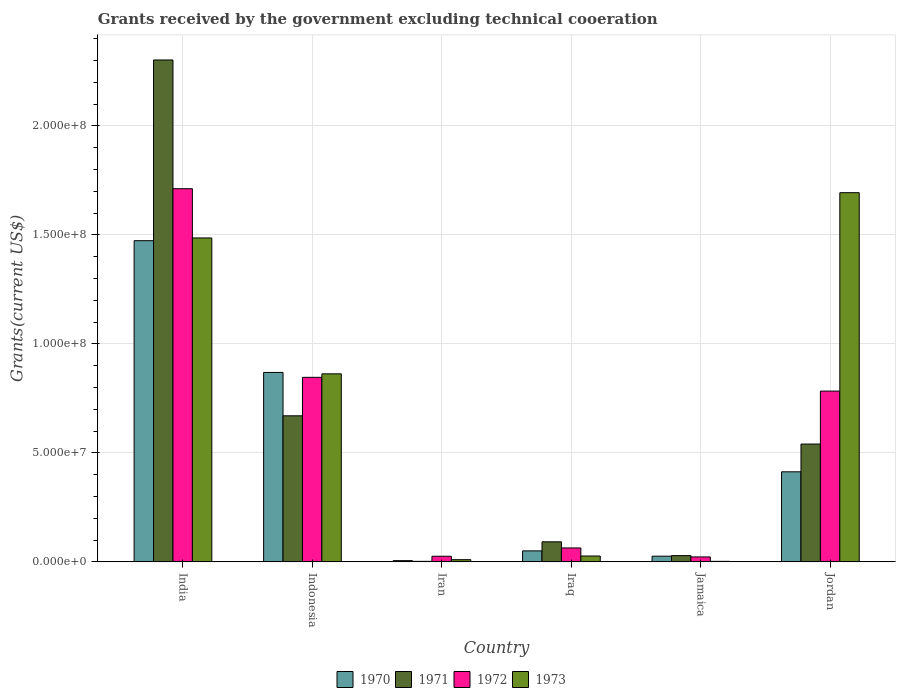Are the number of bars on each tick of the X-axis equal?
Offer a terse response. Yes. How many bars are there on the 6th tick from the right?
Your answer should be compact. 4. What is the label of the 3rd group of bars from the left?
Your answer should be compact. Iran. In how many cases, is the number of bars for a given country not equal to the number of legend labels?
Provide a succinct answer. 0. What is the total grants received by the government in 1973 in Indonesia?
Make the answer very short. 8.63e+07. Across all countries, what is the maximum total grants received by the government in 1970?
Offer a very short reply. 1.47e+08. Across all countries, what is the minimum total grants received by the government in 1973?
Keep it short and to the point. 2.50e+05. In which country was the total grants received by the government in 1972 maximum?
Give a very brief answer. India. In which country was the total grants received by the government in 1971 minimum?
Provide a succinct answer. Iran. What is the total total grants received by the government in 1971 in the graph?
Your response must be concise. 3.64e+08. What is the difference between the total grants received by the government in 1972 in Iran and that in Jamaica?
Ensure brevity in your answer.  3.10e+05. What is the difference between the total grants received by the government in 1972 in Iran and the total grants received by the government in 1970 in Jordan?
Give a very brief answer. -3.87e+07. What is the average total grants received by the government in 1973 per country?
Your answer should be very brief. 6.80e+07. What is the difference between the total grants received by the government of/in 1972 and total grants received by the government of/in 1971 in Indonesia?
Give a very brief answer. 1.76e+07. In how many countries, is the total grants received by the government in 1973 greater than 120000000 US$?
Provide a succinct answer. 2. What is the ratio of the total grants received by the government in 1970 in India to that in Jordan?
Provide a succinct answer. 3.57. What is the difference between the highest and the second highest total grants received by the government in 1973?
Offer a very short reply. 8.31e+07. What is the difference between the highest and the lowest total grants received by the government in 1972?
Offer a terse response. 1.69e+08. What does the 2nd bar from the left in Iraq represents?
Ensure brevity in your answer.  1971. What does the 3rd bar from the right in Jamaica represents?
Make the answer very short. 1971. Is it the case that in every country, the sum of the total grants received by the government in 1972 and total grants received by the government in 1970 is greater than the total grants received by the government in 1973?
Give a very brief answer. No. Are all the bars in the graph horizontal?
Ensure brevity in your answer.  No. How many countries are there in the graph?
Ensure brevity in your answer.  6. What is the difference between two consecutive major ticks on the Y-axis?
Give a very brief answer. 5.00e+07. Does the graph contain any zero values?
Keep it short and to the point. No. Does the graph contain grids?
Your answer should be compact. Yes. Where does the legend appear in the graph?
Your answer should be compact. Bottom center. How are the legend labels stacked?
Your answer should be compact. Horizontal. What is the title of the graph?
Give a very brief answer. Grants received by the government excluding technical cooeration. What is the label or title of the X-axis?
Give a very brief answer. Country. What is the label or title of the Y-axis?
Your answer should be compact. Grants(current US$). What is the Grants(current US$) in 1970 in India?
Offer a very short reply. 1.47e+08. What is the Grants(current US$) of 1971 in India?
Ensure brevity in your answer.  2.30e+08. What is the Grants(current US$) of 1972 in India?
Offer a terse response. 1.71e+08. What is the Grants(current US$) of 1973 in India?
Keep it short and to the point. 1.49e+08. What is the Grants(current US$) in 1970 in Indonesia?
Provide a succinct answer. 8.69e+07. What is the Grants(current US$) of 1971 in Indonesia?
Your answer should be very brief. 6.70e+07. What is the Grants(current US$) in 1972 in Indonesia?
Offer a terse response. 8.47e+07. What is the Grants(current US$) of 1973 in Indonesia?
Offer a very short reply. 8.63e+07. What is the Grants(current US$) of 1970 in Iran?
Your answer should be compact. 5.60e+05. What is the Grants(current US$) in 1971 in Iran?
Make the answer very short. 2.40e+05. What is the Grants(current US$) in 1972 in Iran?
Provide a short and direct response. 2.58e+06. What is the Grants(current US$) in 1973 in Iran?
Provide a short and direct response. 1.01e+06. What is the Grants(current US$) in 1970 in Iraq?
Provide a succinct answer. 5.04e+06. What is the Grants(current US$) of 1971 in Iraq?
Your answer should be compact. 9.20e+06. What is the Grants(current US$) of 1972 in Iraq?
Give a very brief answer. 6.39e+06. What is the Grants(current US$) of 1973 in Iraq?
Make the answer very short. 2.69e+06. What is the Grants(current US$) in 1970 in Jamaica?
Provide a short and direct response. 2.61e+06. What is the Grants(current US$) in 1971 in Jamaica?
Keep it short and to the point. 2.87e+06. What is the Grants(current US$) in 1972 in Jamaica?
Make the answer very short. 2.27e+06. What is the Grants(current US$) of 1970 in Jordan?
Offer a terse response. 4.13e+07. What is the Grants(current US$) in 1971 in Jordan?
Provide a succinct answer. 5.41e+07. What is the Grants(current US$) of 1972 in Jordan?
Make the answer very short. 7.84e+07. What is the Grants(current US$) in 1973 in Jordan?
Give a very brief answer. 1.69e+08. Across all countries, what is the maximum Grants(current US$) in 1970?
Offer a very short reply. 1.47e+08. Across all countries, what is the maximum Grants(current US$) of 1971?
Give a very brief answer. 2.30e+08. Across all countries, what is the maximum Grants(current US$) of 1972?
Your response must be concise. 1.71e+08. Across all countries, what is the maximum Grants(current US$) in 1973?
Keep it short and to the point. 1.69e+08. Across all countries, what is the minimum Grants(current US$) in 1970?
Make the answer very short. 5.60e+05. Across all countries, what is the minimum Grants(current US$) of 1971?
Give a very brief answer. 2.40e+05. Across all countries, what is the minimum Grants(current US$) of 1972?
Your answer should be very brief. 2.27e+06. Across all countries, what is the minimum Grants(current US$) of 1973?
Your answer should be compact. 2.50e+05. What is the total Grants(current US$) of 1970 in the graph?
Make the answer very short. 2.84e+08. What is the total Grants(current US$) in 1971 in the graph?
Your answer should be very brief. 3.64e+08. What is the total Grants(current US$) of 1972 in the graph?
Ensure brevity in your answer.  3.45e+08. What is the total Grants(current US$) of 1973 in the graph?
Give a very brief answer. 4.08e+08. What is the difference between the Grants(current US$) of 1970 in India and that in Indonesia?
Your answer should be compact. 6.04e+07. What is the difference between the Grants(current US$) of 1971 in India and that in Indonesia?
Your response must be concise. 1.63e+08. What is the difference between the Grants(current US$) of 1972 in India and that in Indonesia?
Offer a very short reply. 8.65e+07. What is the difference between the Grants(current US$) of 1973 in India and that in Indonesia?
Provide a short and direct response. 6.23e+07. What is the difference between the Grants(current US$) of 1970 in India and that in Iran?
Keep it short and to the point. 1.47e+08. What is the difference between the Grants(current US$) of 1971 in India and that in Iran?
Provide a short and direct response. 2.30e+08. What is the difference between the Grants(current US$) in 1972 in India and that in Iran?
Your answer should be compact. 1.69e+08. What is the difference between the Grants(current US$) in 1973 in India and that in Iran?
Make the answer very short. 1.48e+08. What is the difference between the Grants(current US$) of 1970 in India and that in Iraq?
Provide a succinct answer. 1.42e+08. What is the difference between the Grants(current US$) in 1971 in India and that in Iraq?
Provide a short and direct response. 2.21e+08. What is the difference between the Grants(current US$) of 1972 in India and that in Iraq?
Keep it short and to the point. 1.65e+08. What is the difference between the Grants(current US$) in 1973 in India and that in Iraq?
Your answer should be compact. 1.46e+08. What is the difference between the Grants(current US$) in 1970 in India and that in Jamaica?
Offer a terse response. 1.45e+08. What is the difference between the Grants(current US$) of 1971 in India and that in Jamaica?
Keep it short and to the point. 2.27e+08. What is the difference between the Grants(current US$) of 1972 in India and that in Jamaica?
Keep it short and to the point. 1.69e+08. What is the difference between the Grants(current US$) of 1973 in India and that in Jamaica?
Your answer should be very brief. 1.48e+08. What is the difference between the Grants(current US$) of 1970 in India and that in Jordan?
Provide a short and direct response. 1.06e+08. What is the difference between the Grants(current US$) of 1971 in India and that in Jordan?
Offer a very short reply. 1.76e+08. What is the difference between the Grants(current US$) of 1972 in India and that in Jordan?
Your response must be concise. 9.28e+07. What is the difference between the Grants(current US$) in 1973 in India and that in Jordan?
Ensure brevity in your answer.  -2.08e+07. What is the difference between the Grants(current US$) of 1970 in Indonesia and that in Iran?
Make the answer very short. 8.64e+07. What is the difference between the Grants(current US$) in 1971 in Indonesia and that in Iran?
Give a very brief answer. 6.68e+07. What is the difference between the Grants(current US$) of 1972 in Indonesia and that in Iran?
Give a very brief answer. 8.21e+07. What is the difference between the Grants(current US$) of 1973 in Indonesia and that in Iran?
Ensure brevity in your answer.  8.53e+07. What is the difference between the Grants(current US$) in 1970 in Indonesia and that in Iraq?
Your response must be concise. 8.19e+07. What is the difference between the Grants(current US$) of 1971 in Indonesia and that in Iraq?
Provide a short and direct response. 5.78e+07. What is the difference between the Grants(current US$) in 1972 in Indonesia and that in Iraq?
Ensure brevity in your answer.  7.83e+07. What is the difference between the Grants(current US$) in 1973 in Indonesia and that in Iraq?
Offer a very short reply. 8.36e+07. What is the difference between the Grants(current US$) in 1970 in Indonesia and that in Jamaica?
Make the answer very short. 8.43e+07. What is the difference between the Grants(current US$) of 1971 in Indonesia and that in Jamaica?
Your answer should be compact. 6.41e+07. What is the difference between the Grants(current US$) in 1972 in Indonesia and that in Jamaica?
Make the answer very short. 8.24e+07. What is the difference between the Grants(current US$) in 1973 in Indonesia and that in Jamaica?
Ensure brevity in your answer.  8.60e+07. What is the difference between the Grants(current US$) in 1970 in Indonesia and that in Jordan?
Your response must be concise. 4.56e+07. What is the difference between the Grants(current US$) of 1971 in Indonesia and that in Jordan?
Offer a very short reply. 1.30e+07. What is the difference between the Grants(current US$) of 1972 in Indonesia and that in Jordan?
Ensure brevity in your answer.  6.31e+06. What is the difference between the Grants(current US$) in 1973 in Indonesia and that in Jordan?
Make the answer very short. -8.31e+07. What is the difference between the Grants(current US$) in 1970 in Iran and that in Iraq?
Provide a short and direct response. -4.48e+06. What is the difference between the Grants(current US$) in 1971 in Iran and that in Iraq?
Ensure brevity in your answer.  -8.96e+06. What is the difference between the Grants(current US$) in 1972 in Iran and that in Iraq?
Your answer should be compact. -3.81e+06. What is the difference between the Grants(current US$) in 1973 in Iran and that in Iraq?
Ensure brevity in your answer.  -1.68e+06. What is the difference between the Grants(current US$) in 1970 in Iran and that in Jamaica?
Give a very brief answer. -2.05e+06. What is the difference between the Grants(current US$) in 1971 in Iran and that in Jamaica?
Give a very brief answer. -2.63e+06. What is the difference between the Grants(current US$) in 1972 in Iran and that in Jamaica?
Provide a short and direct response. 3.10e+05. What is the difference between the Grants(current US$) in 1973 in Iran and that in Jamaica?
Keep it short and to the point. 7.60e+05. What is the difference between the Grants(current US$) of 1970 in Iran and that in Jordan?
Keep it short and to the point. -4.08e+07. What is the difference between the Grants(current US$) in 1971 in Iran and that in Jordan?
Give a very brief answer. -5.38e+07. What is the difference between the Grants(current US$) of 1972 in Iran and that in Jordan?
Give a very brief answer. -7.58e+07. What is the difference between the Grants(current US$) of 1973 in Iran and that in Jordan?
Offer a terse response. -1.68e+08. What is the difference between the Grants(current US$) of 1970 in Iraq and that in Jamaica?
Keep it short and to the point. 2.43e+06. What is the difference between the Grants(current US$) of 1971 in Iraq and that in Jamaica?
Offer a terse response. 6.33e+06. What is the difference between the Grants(current US$) of 1972 in Iraq and that in Jamaica?
Offer a very short reply. 4.12e+06. What is the difference between the Grants(current US$) of 1973 in Iraq and that in Jamaica?
Offer a terse response. 2.44e+06. What is the difference between the Grants(current US$) in 1970 in Iraq and that in Jordan?
Your answer should be compact. -3.63e+07. What is the difference between the Grants(current US$) of 1971 in Iraq and that in Jordan?
Ensure brevity in your answer.  -4.49e+07. What is the difference between the Grants(current US$) of 1972 in Iraq and that in Jordan?
Give a very brief answer. -7.20e+07. What is the difference between the Grants(current US$) in 1973 in Iraq and that in Jordan?
Make the answer very short. -1.67e+08. What is the difference between the Grants(current US$) in 1970 in Jamaica and that in Jordan?
Provide a succinct answer. -3.87e+07. What is the difference between the Grants(current US$) of 1971 in Jamaica and that in Jordan?
Your answer should be compact. -5.12e+07. What is the difference between the Grants(current US$) in 1972 in Jamaica and that in Jordan?
Give a very brief answer. -7.61e+07. What is the difference between the Grants(current US$) in 1973 in Jamaica and that in Jordan?
Your answer should be compact. -1.69e+08. What is the difference between the Grants(current US$) of 1970 in India and the Grants(current US$) of 1971 in Indonesia?
Keep it short and to the point. 8.03e+07. What is the difference between the Grants(current US$) of 1970 in India and the Grants(current US$) of 1972 in Indonesia?
Provide a succinct answer. 6.27e+07. What is the difference between the Grants(current US$) of 1970 in India and the Grants(current US$) of 1973 in Indonesia?
Make the answer very short. 6.11e+07. What is the difference between the Grants(current US$) in 1971 in India and the Grants(current US$) in 1972 in Indonesia?
Your answer should be very brief. 1.46e+08. What is the difference between the Grants(current US$) of 1971 in India and the Grants(current US$) of 1973 in Indonesia?
Provide a short and direct response. 1.44e+08. What is the difference between the Grants(current US$) in 1972 in India and the Grants(current US$) in 1973 in Indonesia?
Make the answer very short. 8.49e+07. What is the difference between the Grants(current US$) of 1970 in India and the Grants(current US$) of 1971 in Iran?
Ensure brevity in your answer.  1.47e+08. What is the difference between the Grants(current US$) in 1970 in India and the Grants(current US$) in 1972 in Iran?
Make the answer very short. 1.45e+08. What is the difference between the Grants(current US$) of 1970 in India and the Grants(current US$) of 1973 in Iran?
Make the answer very short. 1.46e+08. What is the difference between the Grants(current US$) in 1971 in India and the Grants(current US$) in 1972 in Iran?
Provide a succinct answer. 2.28e+08. What is the difference between the Grants(current US$) of 1971 in India and the Grants(current US$) of 1973 in Iran?
Offer a very short reply. 2.29e+08. What is the difference between the Grants(current US$) of 1972 in India and the Grants(current US$) of 1973 in Iran?
Make the answer very short. 1.70e+08. What is the difference between the Grants(current US$) in 1970 in India and the Grants(current US$) in 1971 in Iraq?
Your answer should be very brief. 1.38e+08. What is the difference between the Grants(current US$) in 1970 in India and the Grants(current US$) in 1972 in Iraq?
Keep it short and to the point. 1.41e+08. What is the difference between the Grants(current US$) of 1970 in India and the Grants(current US$) of 1973 in Iraq?
Give a very brief answer. 1.45e+08. What is the difference between the Grants(current US$) of 1971 in India and the Grants(current US$) of 1972 in Iraq?
Give a very brief answer. 2.24e+08. What is the difference between the Grants(current US$) of 1971 in India and the Grants(current US$) of 1973 in Iraq?
Provide a succinct answer. 2.28e+08. What is the difference between the Grants(current US$) of 1972 in India and the Grants(current US$) of 1973 in Iraq?
Offer a terse response. 1.69e+08. What is the difference between the Grants(current US$) of 1970 in India and the Grants(current US$) of 1971 in Jamaica?
Keep it short and to the point. 1.44e+08. What is the difference between the Grants(current US$) in 1970 in India and the Grants(current US$) in 1972 in Jamaica?
Your answer should be compact. 1.45e+08. What is the difference between the Grants(current US$) in 1970 in India and the Grants(current US$) in 1973 in Jamaica?
Provide a short and direct response. 1.47e+08. What is the difference between the Grants(current US$) in 1971 in India and the Grants(current US$) in 1972 in Jamaica?
Offer a very short reply. 2.28e+08. What is the difference between the Grants(current US$) of 1971 in India and the Grants(current US$) of 1973 in Jamaica?
Ensure brevity in your answer.  2.30e+08. What is the difference between the Grants(current US$) in 1972 in India and the Grants(current US$) in 1973 in Jamaica?
Make the answer very short. 1.71e+08. What is the difference between the Grants(current US$) in 1970 in India and the Grants(current US$) in 1971 in Jordan?
Provide a succinct answer. 9.33e+07. What is the difference between the Grants(current US$) of 1970 in India and the Grants(current US$) of 1972 in Jordan?
Offer a very short reply. 6.90e+07. What is the difference between the Grants(current US$) of 1970 in India and the Grants(current US$) of 1973 in Jordan?
Provide a succinct answer. -2.20e+07. What is the difference between the Grants(current US$) of 1971 in India and the Grants(current US$) of 1972 in Jordan?
Ensure brevity in your answer.  1.52e+08. What is the difference between the Grants(current US$) in 1971 in India and the Grants(current US$) in 1973 in Jordan?
Your answer should be very brief. 6.09e+07. What is the difference between the Grants(current US$) of 1972 in India and the Grants(current US$) of 1973 in Jordan?
Offer a very short reply. 1.82e+06. What is the difference between the Grants(current US$) in 1970 in Indonesia and the Grants(current US$) in 1971 in Iran?
Give a very brief answer. 8.67e+07. What is the difference between the Grants(current US$) of 1970 in Indonesia and the Grants(current US$) of 1972 in Iran?
Your response must be concise. 8.43e+07. What is the difference between the Grants(current US$) of 1970 in Indonesia and the Grants(current US$) of 1973 in Iran?
Give a very brief answer. 8.59e+07. What is the difference between the Grants(current US$) of 1971 in Indonesia and the Grants(current US$) of 1972 in Iran?
Give a very brief answer. 6.44e+07. What is the difference between the Grants(current US$) in 1971 in Indonesia and the Grants(current US$) in 1973 in Iran?
Make the answer very short. 6.60e+07. What is the difference between the Grants(current US$) in 1972 in Indonesia and the Grants(current US$) in 1973 in Iran?
Make the answer very short. 8.36e+07. What is the difference between the Grants(current US$) of 1970 in Indonesia and the Grants(current US$) of 1971 in Iraq?
Provide a short and direct response. 7.77e+07. What is the difference between the Grants(current US$) in 1970 in Indonesia and the Grants(current US$) in 1972 in Iraq?
Offer a very short reply. 8.05e+07. What is the difference between the Grants(current US$) of 1970 in Indonesia and the Grants(current US$) of 1973 in Iraq?
Ensure brevity in your answer.  8.42e+07. What is the difference between the Grants(current US$) of 1971 in Indonesia and the Grants(current US$) of 1972 in Iraq?
Your answer should be compact. 6.06e+07. What is the difference between the Grants(current US$) in 1971 in Indonesia and the Grants(current US$) in 1973 in Iraq?
Your response must be concise. 6.43e+07. What is the difference between the Grants(current US$) in 1972 in Indonesia and the Grants(current US$) in 1973 in Iraq?
Ensure brevity in your answer.  8.20e+07. What is the difference between the Grants(current US$) in 1970 in Indonesia and the Grants(current US$) in 1971 in Jamaica?
Your response must be concise. 8.40e+07. What is the difference between the Grants(current US$) in 1970 in Indonesia and the Grants(current US$) in 1972 in Jamaica?
Your answer should be compact. 8.46e+07. What is the difference between the Grants(current US$) of 1970 in Indonesia and the Grants(current US$) of 1973 in Jamaica?
Your response must be concise. 8.67e+07. What is the difference between the Grants(current US$) in 1971 in Indonesia and the Grants(current US$) in 1972 in Jamaica?
Give a very brief answer. 6.47e+07. What is the difference between the Grants(current US$) in 1971 in Indonesia and the Grants(current US$) in 1973 in Jamaica?
Provide a succinct answer. 6.68e+07. What is the difference between the Grants(current US$) in 1972 in Indonesia and the Grants(current US$) in 1973 in Jamaica?
Provide a short and direct response. 8.44e+07. What is the difference between the Grants(current US$) of 1970 in Indonesia and the Grants(current US$) of 1971 in Jordan?
Keep it short and to the point. 3.28e+07. What is the difference between the Grants(current US$) of 1970 in Indonesia and the Grants(current US$) of 1972 in Jordan?
Ensure brevity in your answer.  8.56e+06. What is the difference between the Grants(current US$) of 1970 in Indonesia and the Grants(current US$) of 1973 in Jordan?
Your answer should be compact. -8.25e+07. What is the difference between the Grants(current US$) in 1971 in Indonesia and the Grants(current US$) in 1972 in Jordan?
Provide a short and direct response. -1.13e+07. What is the difference between the Grants(current US$) of 1971 in Indonesia and the Grants(current US$) of 1973 in Jordan?
Give a very brief answer. -1.02e+08. What is the difference between the Grants(current US$) of 1972 in Indonesia and the Grants(current US$) of 1973 in Jordan?
Offer a terse response. -8.47e+07. What is the difference between the Grants(current US$) in 1970 in Iran and the Grants(current US$) in 1971 in Iraq?
Make the answer very short. -8.64e+06. What is the difference between the Grants(current US$) in 1970 in Iran and the Grants(current US$) in 1972 in Iraq?
Give a very brief answer. -5.83e+06. What is the difference between the Grants(current US$) in 1970 in Iran and the Grants(current US$) in 1973 in Iraq?
Provide a short and direct response. -2.13e+06. What is the difference between the Grants(current US$) in 1971 in Iran and the Grants(current US$) in 1972 in Iraq?
Keep it short and to the point. -6.15e+06. What is the difference between the Grants(current US$) in 1971 in Iran and the Grants(current US$) in 1973 in Iraq?
Keep it short and to the point. -2.45e+06. What is the difference between the Grants(current US$) of 1972 in Iran and the Grants(current US$) of 1973 in Iraq?
Your response must be concise. -1.10e+05. What is the difference between the Grants(current US$) in 1970 in Iran and the Grants(current US$) in 1971 in Jamaica?
Provide a short and direct response. -2.31e+06. What is the difference between the Grants(current US$) of 1970 in Iran and the Grants(current US$) of 1972 in Jamaica?
Provide a short and direct response. -1.71e+06. What is the difference between the Grants(current US$) of 1971 in Iran and the Grants(current US$) of 1972 in Jamaica?
Offer a terse response. -2.03e+06. What is the difference between the Grants(current US$) of 1971 in Iran and the Grants(current US$) of 1973 in Jamaica?
Your answer should be very brief. -10000. What is the difference between the Grants(current US$) of 1972 in Iran and the Grants(current US$) of 1973 in Jamaica?
Offer a terse response. 2.33e+06. What is the difference between the Grants(current US$) in 1970 in Iran and the Grants(current US$) in 1971 in Jordan?
Your answer should be very brief. -5.35e+07. What is the difference between the Grants(current US$) of 1970 in Iran and the Grants(current US$) of 1972 in Jordan?
Provide a short and direct response. -7.78e+07. What is the difference between the Grants(current US$) of 1970 in Iran and the Grants(current US$) of 1973 in Jordan?
Offer a terse response. -1.69e+08. What is the difference between the Grants(current US$) of 1971 in Iran and the Grants(current US$) of 1972 in Jordan?
Your answer should be very brief. -7.81e+07. What is the difference between the Grants(current US$) in 1971 in Iran and the Grants(current US$) in 1973 in Jordan?
Keep it short and to the point. -1.69e+08. What is the difference between the Grants(current US$) in 1972 in Iran and the Grants(current US$) in 1973 in Jordan?
Your response must be concise. -1.67e+08. What is the difference between the Grants(current US$) in 1970 in Iraq and the Grants(current US$) in 1971 in Jamaica?
Your response must be concise. 2.17e+06. What is the difference between the Grants(current US$) in 1970 in Iraq and the Grants(current US$) in 1972 in Jamaica?
Make the answer very short. 2.77e+06. What is the difference between the Grants(current US$) of 1970 in Iraq and the Grants(current US$) of 1973 in Jamaica?
Your answer should be very brief. 4.79e+06. What is the difference between the Grants(current US$) of 1971 in Iraq and the Grants(current US$) of 1972 in Jamaica?
Offer a terse response. 6.93e+06. What is the difference between the Grants(current US$) in 1971 in Iraq and the Grants(current US$) in 1973 in Jamaica?
Your response must be concise. 8.95e+06. What is the difference between the Grants(current US$) in 1972 in Iraq and the Grants(current US$) in 1973 in Jamaica?
Offer a terse response. 6.14e+06. What is the difference between the Grants(current US$) in 1970 in Iraq and the Grants(current US$) in 1971 in Jordan?
Make the answer very short. -4.90e+07. What is the difference between the Grants(current US$) of 1970 in Iraq and the Grants(current US$) of 1972 in Jordan?
Provide a short and direct response. -7.33e+07. What is the difference between the Grants(current US$) of 1970 in Iraq and the Grants(current US$) of 1973 in Jordan?
Give a very brief answer. -1.64e+08. What is the difference between the Grants(current US$) of 1971 in Iraq and the Grants(current US$) of 1972 in Jordan?
Your answer should be very brief. -6.92e+07. What is the difference between the Grants(current US$) of 1971 in Iraq and the Grants(current US$) of 1973 in Jordan?
Ensure brevity in your answer.  -1.60e+08. What is the difference between the Grants(current US$) in 1972 in Iraq and the Grants(current US$) in 1973 in Jordan?
Your response must be concise. -1.63e+08. What is the difference between the Grants(current US$) in 1970 in Jamaica and the Grants(current US$) in 1971 in Jordan?
Offer a very short reply. -5.14e+07. What is the difference between the Grants(current US$) of 1970 in Jamaica and the Grants(current US$) of 1972 in Jordan?
Offer a terse response. -7.57e+07. What is the difference between the Grants(current US$) in 1970 in Jamaica and the Grants(current US$) in 1973 in Jordan?
Provide a short and direct response. -1.67e+08. What is the difference between the Grants(current US$) in 1971 in Jamaica and the Grants(current US$) in 1972 in Jordan?
Ensure brevity in your answer.  -7.55e+07. What is the difference between the Grants(current US$) in 1971 in Jamaica and the Grants(current US$) in 1973 in Jordan?
Provide a succinct answer. -1.67e+08. What is the difference between the Grants(current US$) in 1972 in Jamaica and the Grants(current US$) in 1973 in Jordan?
Your answer should be compact. -1.67e+08. What is the average Grants(current US$) in 1970 per country?
Offer a very short reply. 4.73e+07. What is the average Grants(current US$) in 1971 per country?
Offer a terse response. 6.06e+07. What is the average Grants(current US$) of 1972 per country?
Provide a short and direct response. 5.76e+07. What is the average Grants(current US$) in 1973 per country?
Offer a terse response. 6.80e+07. What is the difference between the Grants(current US$) in 1970 and Grants(current US$) in 1971 in India?
Give a very brief answer. -8.29e+07. What is the difference between the Grants(current US$) in 1970 and Grants(current US$) in 1972 in India?
Make the answer very short. -2.38e+07. What is the difference between the Grants(current US$) of 1970 and Grants(current US$) of 1973 in India?
Make the answer very short. -1.26e+06. What is the difference between the Grants(current US$) in 1971 and Grants(current US$) in 1972 in India?
Your answer should be very brief. 5.91e+07. What is the difference between the Grants(current US$) in 1971 and Grants(current US$) in 1973 in India?
Your answer should be very brief. 8.16e+07. What is the difference between the Grants(current US$) in 1972 and Grants(current US$) in 1973 in India?
Your answer should be very brief. 2.26e+07. What is the difference between the Grants(current US$) in 1970 and Grants(current US$) in 1971 in Indonesia?
Ensure brevity in your answer.  1.99e+07. What is the difference between the Grants(current US$) in 1970 and Grants(current US$) in 1972 in Indonesia?
Give a very brief answer. 2.25e+06. What is the difference between the Grants(current US$) of 1970 and Grants(current US$) of 1973 in Indonesia?
Provide a short and direct response. 6.40e+05. What is the difference between the Grants(current US$) in 1971 and Grants(current US$) in 1972 in Indonesia?
Provide a short and direct response. -1.76e+07. What is the difference between the Grants(current US$) of 1971 and Grants(current US$) of 1973 in Indonesia?
Provide a succinct answer. -1.93e+07. What is the difference between the Grants(current US$) of 1972 and Grants(current US$) of 1973 in Indonesia?
Offer a terse response. -1.61e+06. What is the difference between the Grants(current US$) of 1970 and Grants(current US$) of 1971 in Iran?
Make the answer very short. 3.20e+05. What is the difference between the Grants(current US$) of 1970 and Grants(current US$) of 1972 in Iran?
Your answer should be compact. -2.02e+06. What is the difference between the Grants(current US$) of 1970 and Grants(current US$) of 1973 in Iran?
Your response must be concise. -4.50e+05. What is the difference between the Grants(current US$) in 1971 and Grants(current US$) in 1972 in Iran?
Offer a terse response. -2.34e+06. What is the difference between the Grants(current US$) of 1971 and Grants(current US$) of 1973 in Iran?
Provide a short and direct response. -7.70e+05. What is the difference between the Grants(current US$) in 1972 and Grants(current US$) in 1973 in Iran?
Offer a very short reply. 1.57e+06. What is the difference between the Grants(current US$) of 1970 and Grants(current US$) of 1971 in Iraq?
Make the answer very short. -4.16e+06. What is the difference between the Grants(current US$) of 1970 and Grants(current US$) of 1972 in Iraq?
Provide a succinct answer. -1.35e+06. What is the difference between the Grants(current US$) in 1970 and Grants(current US$) in 1973 in Iraq?
Ensure brevity in your answer.  2.35e+06. What is the difference between the Grants(current US$) of 1971 and Grants(current US$) of 1972 in Iraq?
Keep it short and to the point. 2.81e+06. What is the difference between the Grants(current US$) of 1971 and Grants(current US$) of 1973 in Iraq?
Ensure brevity in your answer.  6.51e+06. What is the difference between the Grants(current US$) of 1972 and Grants(current US$) of 1973 in Iraq?
Provide a succinct answer. 3.70e+06. What is the difference between the Grants(current US$) of 1970 and Grants(current US$) of 1972 in Jamaica?
Provide a succinct answer. 3.40e+05. What is the difference between the Grants(current US$) in 1970 and Grants(current US$) in 1973 in Jamaica?
Ensure brevity in your answer.  2.36e+06. What is the difference between the Grants(current US$) in 1971 and Grants(current US$) in 1972 in Jamaica?
Offer a terse response. 6.00e+05. What is the difference between the Grants(current US$) of 1971 and Grants(current US$) of 1973 in Jamaica?
Your answer should be very brief. 2.62e+06. What is the difference between the Grants(current US$) of 1972 and Grants(current US$) of 1973 in Jamaica?
Make the answer very short. 2.02e+06. What is the difference between the Grants(current US$) of 1970 and Grants(current US$) of 1971 in Jordan?
Ensure brevity in your answer.  -1.27e+07. What is the difference between the Grants(current US$) of 1970 and Grants(current US$) of 1972 in Jordan?
Make the answer very short. -3.70e+07. What is the difference between the Grants(current US$) of 1970 and Grants(current US$) of 1973 in Jordan?
Your answer should be very brief. -1.28e+08. What is the difference between the Grants(current US$) in 1971 and Grants(current US$) in 1972 in Jordan?
Provide a short and direct response. -2.43e+07. What is the difference between the Grants(current US$) of 1971 and Grants(current US$) of 1973 in Jordan?
Ensure brevity in your answer.  -1.15e+08. What is the difference between the Grants(current US$) of 1972 and Grants(current US$) of 1973 in Jordan?
Your answer should be compact. -9.10e+07. What is the ratio of the Grants(current US$) in 1970 in India to that in Indonesia?
Keep it short and to the point. 1.7. What is the ratio of the Grants(current US$) in 1971 in India to that in Indonesia?
Offer a very short reply. 3.44. What is the ratio of the Grants(current US$) of 1972 in India to that in Indonesia?
Keep it short and to the point. 2.02. What is the ratio of the Grants(current US$) of 1973 in India to that in Indonesia?
Keep it short and to the point. 1.72. What is the ratio of the Grants(current US$) in 1970 in India to that in Iran?
Ensure brevity in your answer.  263.12. What is the ratio of the Grants(current US$) of 1971 in India to that in Iran?
Provide a succinct answer. 959.42. What is the ratio of the Grants(current US$) in 1972 in India to that in Iran?
Your answer should be compact. 66.36. What is the ratio of the Grants(current US$) in 1973 in India to that in Iran?
Provide a succinct answer. 147.14. What is the ratio of the Grants(current US$) in 1970 in India to that in Iraq?
Offer a very short reply. 29.24. What is the ratio of the Grants(current US$) in 1971 in India to that in Iraq?
Your answer should be very brief. 25.03. What is the ratio of the Grants(current US$) of 1972 in India to that in Iraq?
Ensure brevity in your answer.  26.79. What is the ratio of the Grants(current US$) of 1973 in India to that in Iraq?
Your answer should be very brief. 55.25. What is the ratio of the Grants(current US$) of 1970 in India to that in Jamaica?
Offer a very short reply. 56.46. What is the ratio of the Grants(current US$) of 1971 in India to that in Jamaica?
Your answer should be compact. 80.23. What is the ratio of the Grants(current US$) of 1972 in India to that in Jamaica?
Provide a short and direct response. 75.42. What is the ratio of the Grants(current US$) in 1973 in India to that in Jamaica?
Offer a terse response. 594.44. What is the ratio of the Grants(current US$) in 1970 in India to that in Jordan?
Give a very brief answer. 3.57. What is the ratio of the Grants(current US$) of 1971 in India to that in Jordan?
Your response must be concise. 4.26. What is the ratio of the Grants(current US$) of 1972 in India to that in Jordan?
Your answer should be compact. 2.19. What is the ratio of the Grants(current US$) of 1973 in India to that in Jordan?
Your answer should be very brief. 0.88. What is the ratio of the Grants(current US$) in 1970 in Indonesia to that in Iran?
Give a very brief answer. 155.2. What is the ratio of the Grants(current US$) in 1971 in Indonesia to that in Iran?
Your answer should be very brief. 279.21. What is the ratio of the Grants(current US$) of 1972 in Indonesia to that in Iran?
Your response must be concise. 32.81. What is the ratio of the Grants(current US$) of 1973 in Indonesia to that in Iran?
Make the answer very short. 85.42. What is the ratio of the Grants(current US$) of 1970 in Indonesia to that in Iraq?
Your answer should be compact. 17.24. What is the ratio of the Grants(current US$) in 1971 in Indonesia to that in Iraq?
Provide a succinct answer. 7.28. What is the ratio of the Grants(current US$) of 1972 in Indonesia to that in Iraq?
Your response must be concise. 13.25. What is the ratio of the Grants(current US$) of 1973 in Indonesia to that in Iraq?
Provide a succinct answer. 32.07. What is the ratio of the Grants(current US$) in 1970 in Indonesia to that in Jamaica?
Offer a terse response. 33.3. What is the ratio of the Grants(current US$) of 1971 in Indonesia to that in Jamaica?
Offer a very short reply. 23.35. What is the ratio of the Grants(current US$) of 1972 in Indonesia to that in Jamaica?
Keep it short and to the point. 37.3. What is the ratio of the Grants(current US$) in 1973 in Indonesia to that in Jamaica?
Offer a very short reply. 345.08. What is the ratio of the Grants(current US$) in 1970 in Indonesia to that in Jordan?
Offer a very short reply. 2.1. What is the ratio of the Grants(current US$) in 1971 in Indonesia to that in Jordan?
Provide a succinct answer. 1.24. What is the ratio of the Grants(current US$) in 1972 in Indonesia to that in Jordan?
Ensure brevity in your answer.  1.08. What is the ratio of the Grants(current US$) of 1973 in Indonesia to that in Jordan?
Provide a succinct answer. 0.51. What is the ratio of the Grants(current US$) in 1971 in Iran to that in Iraq?
Give a very brief answer. 0.03. What is the ratio of the Grants(current US$) in 1972 in Iran to that in Iraq?
Ensure brevity in your answer.  0.4. What is the ratio of the Grants(current US$) of 1973 in Iran to that in Iraq?
Provide a succinct answer. 0.38. What is the ratio of the Grants(current US$) of 1970 in Iran to that in Jamaica?
Offer a terse response. 0.21. What is the ratio of the Grants(current US$) of 1971 in Iran to that in Jamaica?
Offer a very short reply. 0.08. What is the ratio of the Grants(current US$) of 1972 in Iran to that in Jamaica?
Make the answer very short. 1.14. What is the ratio of the Grants(current US$) in 1973 in Iran to that in Jamaica?
Your answer should be compact. 4.04. What is the ratio of the Grants(current US$) in 1970 in Iran to that in Jordan?
Ensure brevity in your answer.  0.01. What is the ratio of the Grants(current US$) of 1971 in Iran to that in Jordan?
Give a very brief answer. 0. What is the ratio of the Grants(current US$) in 1972 in Iran to that in Jordan?
Offer a terse response. 0.03. What is the ratio of the Grants(current US$) in 1973 in Iran to that in Jordan?
Make the answer very short. 0.01. What is the ratio of the Grants(current US$) of 1970 in Iraq to that in Jamaica?
Your response must be concise. 1.93. What is the ratio of the Grants(current US$) of 1971 in Iraq to that in Jamaica?
Ensure brevity in your answer.  3.21. What is the ratio of the Grants(current US$) in 1972 in Iraq to that in Jamaica?
Make the answer very short. 2.81. What is the ratio of the Grants(current US$) in 1973 in Iraq to that in Jamaica?
Your response must be concise. 10.76. What is the ratio of the Grants(current US$) of 1970 in Iraq to that in Jordan?
Provide a short and direct response. 0.12. What is the ratio of the Grants(current US$) of 1971 in Iraq to that in Jordan?
Offer a very short reply. 0.17. What is the ratio of the Grants(current US$) of 1972 in Iraq to that in Jordan?
Offer a terse response. 0.08. What is the ratio of the Grants(current US$) of 1973 in Iraq to that in Jordan?
Provide a succinct answer. 0.02. What is the ratio of the Grants(current US$) in 1970 in Jamaica to that in Jordan?
Your answer should be compact. 0.06. What is the ratio of the Grants(current US$) of 1971 in Jamaica to that in Jordan?
Give a very brief answer. 0.05. What is the ratio of the Grants(current US$) of 1972 in Jamaica to that in Jordan?
Provide a short and direct response. 0.03. What is the ratio of the Grants(current US$) of 1973 in Jamaica to that in Jordan?
Keep it short and to the point. 0. What is the difference between the highest and the second highest Grants(current US$) of 1970?
Offer a very short reply. 6.04e+07. What is the difference between the highest and the second highest Grants(current US$) of 1971?
Keep it short and to the point. 1.63e+08. What is the difference between the highest and the second highest Grants(current US$) in 1972?
Your response must be concise. 8.65e+07. What is the difference between the highest and the second highest Grants(current US$) in 1973?
Make the answer very short. 2.08e+07. What is the difference between the highest and the lowest Grants(current US$) of 1970?
Provide a succinct answer. 1.47e+08. What is the difference between the highest and the lowest Grants(current US$) in 1971?
Ensure brevity in your answer.  2.30e+08. What is the difference between the highest and the lowest Grants(current US$) in 1972?
Your response must be concise. 1.69e+08. What is the difference between the highest and the lowest Grants(current US$) in 1973?
Offer a very short reply. 1.69e+08. 